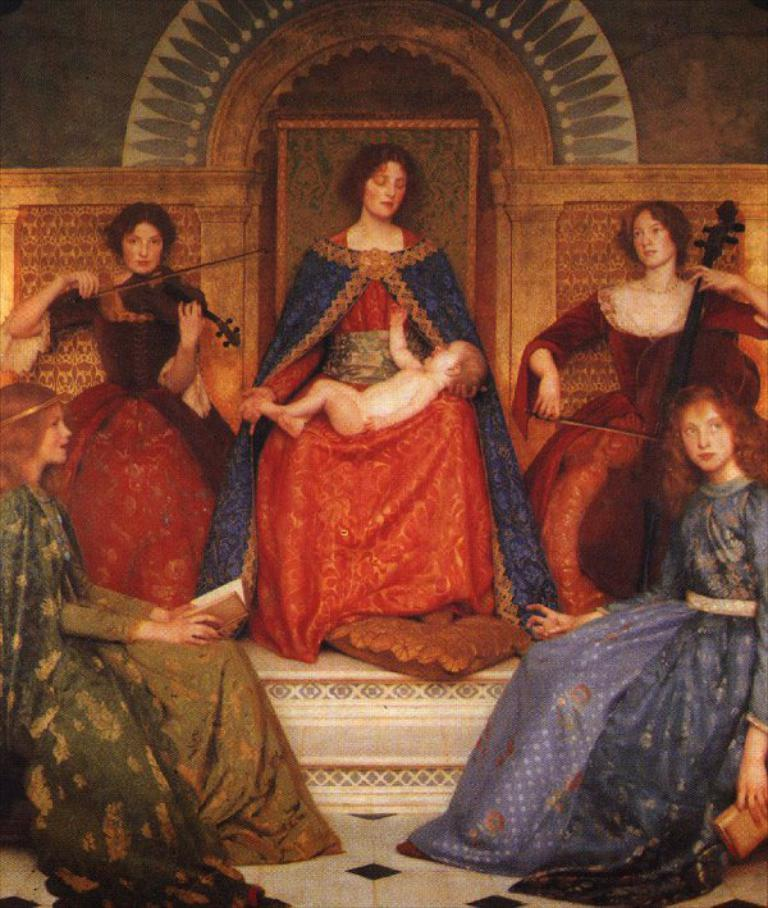What type of image is being described? The image is graphical in nature. How many people are depicted in the image? There are 5 people sitting in the image. Where are the people playing the violin located? Two people are playing the violin on the left side of the image, and two people are playing the violin on the right side of the image. What type of frame is around the yam in the image? There is no yam or frame present in the image; it features people playing the violin. 